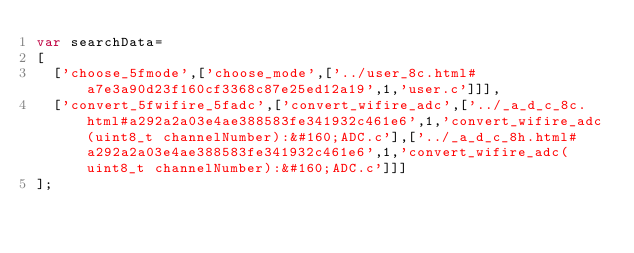Convert code to text. <code><loc_0><loc_0><loc_500><loc_500><_JavaScript_>var searchData=
[
  ['choose_5fmode',['choose_mode',['../user_8c.html#a7e3a90d23f160cf3368c87e25ed12a19',1,'user.c']]],
  ['convert_5fwifire_5fadc',['convert_wifire_adc',['../_a_d_c_8c.html#a292a2a03e4ae388583fe341932c461e6',1,'convert_wifire_adc(uint8_t channelNumber):&#160;ADC.c'],['../_a_d_c_8h.html#a292a2a03e4ae388583fe341932c461e6',1,'convert_wifire_adc(uint8_t channelNumber):&#160;ADC.c']]]
];
</code> 